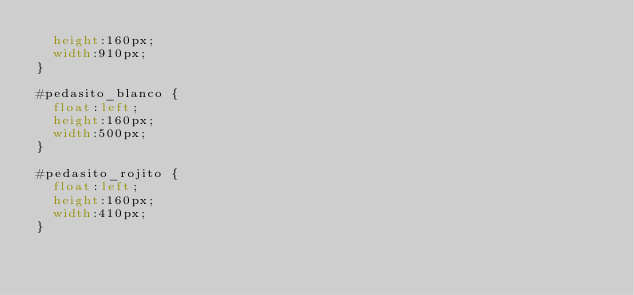<code> <loc_0><loc_0><loc_500><loc_500><_CSS_>	height:160px;
	width:910px;
}

#pedasito_blanco {
	float:left;
	height:160px;
	width:500px;	
}

#pedasito_rojito {
	float:left;
	height:160px;
	width:410px;
}
</code> 